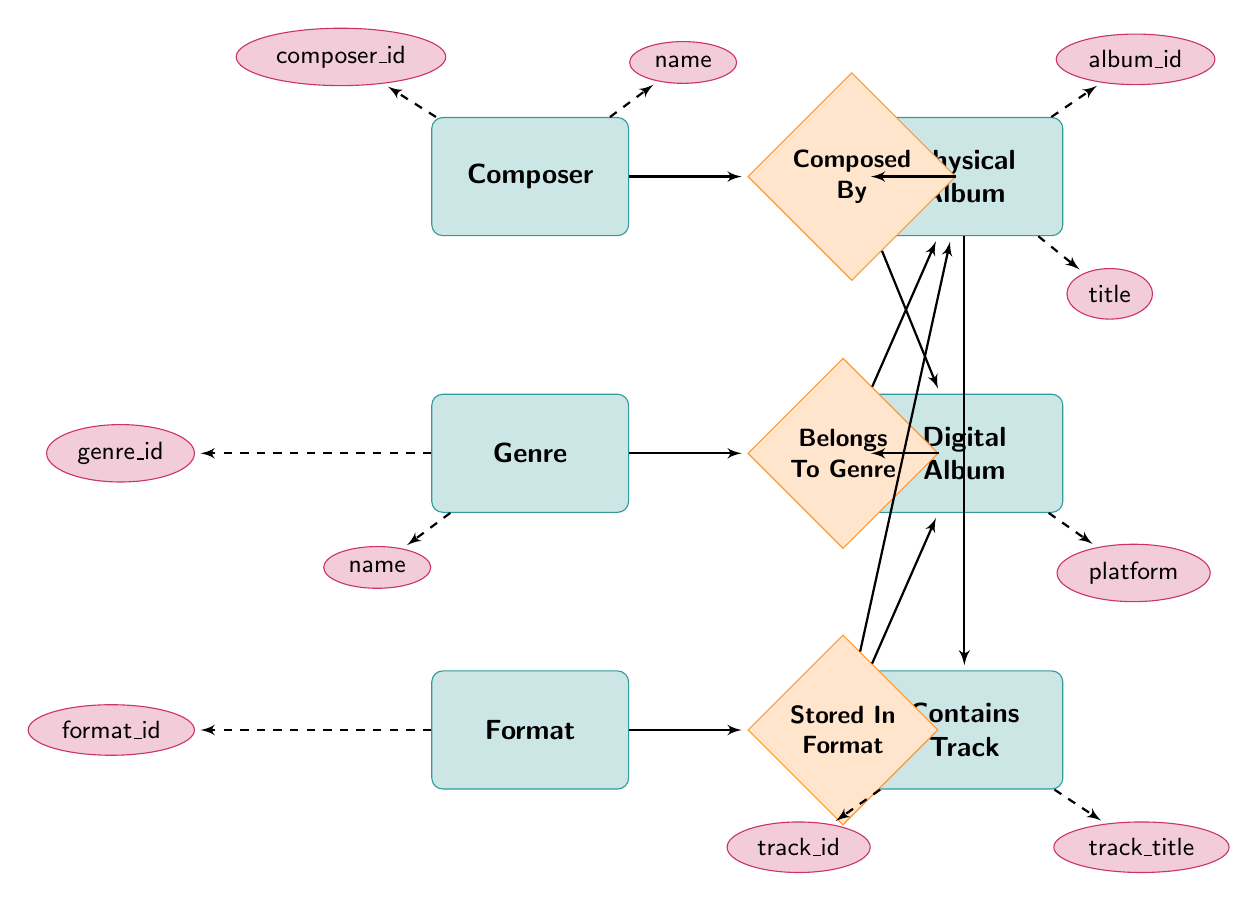What is the primary relationship connecting Physical Album and Composer? The diagram shows that the Physical Album is connected to the Composer through the "Composed By" relationship. Thus, this relationship establishes that a composer is the creator of the physical album.
Answer: Composed By How many main entities are in the diagram? The diagram features six main entities: Composer, Genre, Format, Physical Album, Digital Album, and Contains Track. Counting each one leads to this total.
Answer: 6 Which entity has the attribute 'release_year'? The attributes for the entities are listed, and 'release_year' is associated with both Physical Album and Digital Album. Thus, both of these entities feature this attribute.
Answer: Physical Album, Digital Album What is the relationship between Digital Album and Genre? The relationship diagram indicates that Digital Album has a "Belongs To Genre" relationship with Genre, which signifies that each digital album is categorized under a specific genre.
Answer: Belongs To Genre Which format is associated with both Physical Album and Digital Album? The diagram indicates that both Physical Album and Digital Album share the relationship "Stored In Format," which defines the format in which the music is stored for each type of album.
Answer: Stored In Format What kind of entity is 'Contains Track'? In the diagram, 'Contains Track' is classified as a relationship entity, highlighting its role in forming connections between tracks and the albums that contain them.
Answer: Relationship How many relationships connect to the Physical Album entity? Upon reviewing the diagram, the Physical Album has three distinct relationships: "Composed By," "Belongs To Genre," and "Stored In Format," connecting it to the Composer, Genre, and Format respectively.
Answer: 3 Which entity contains the attribute 'platform'? The attribute 'platform' is specifically listed under the Digital Album entity, indicating that this attribute is relevant solely to digital formats and their storage platforms.
Answer: Digital Album What links the Contains Track entity to both Physical Album and Digital Album? The diagram illustrates that the "Contains" relationship is the connecting link between both album types and the Contains Track entity, indicating that albums include specific tracks in their collection.
Answer: Contains 